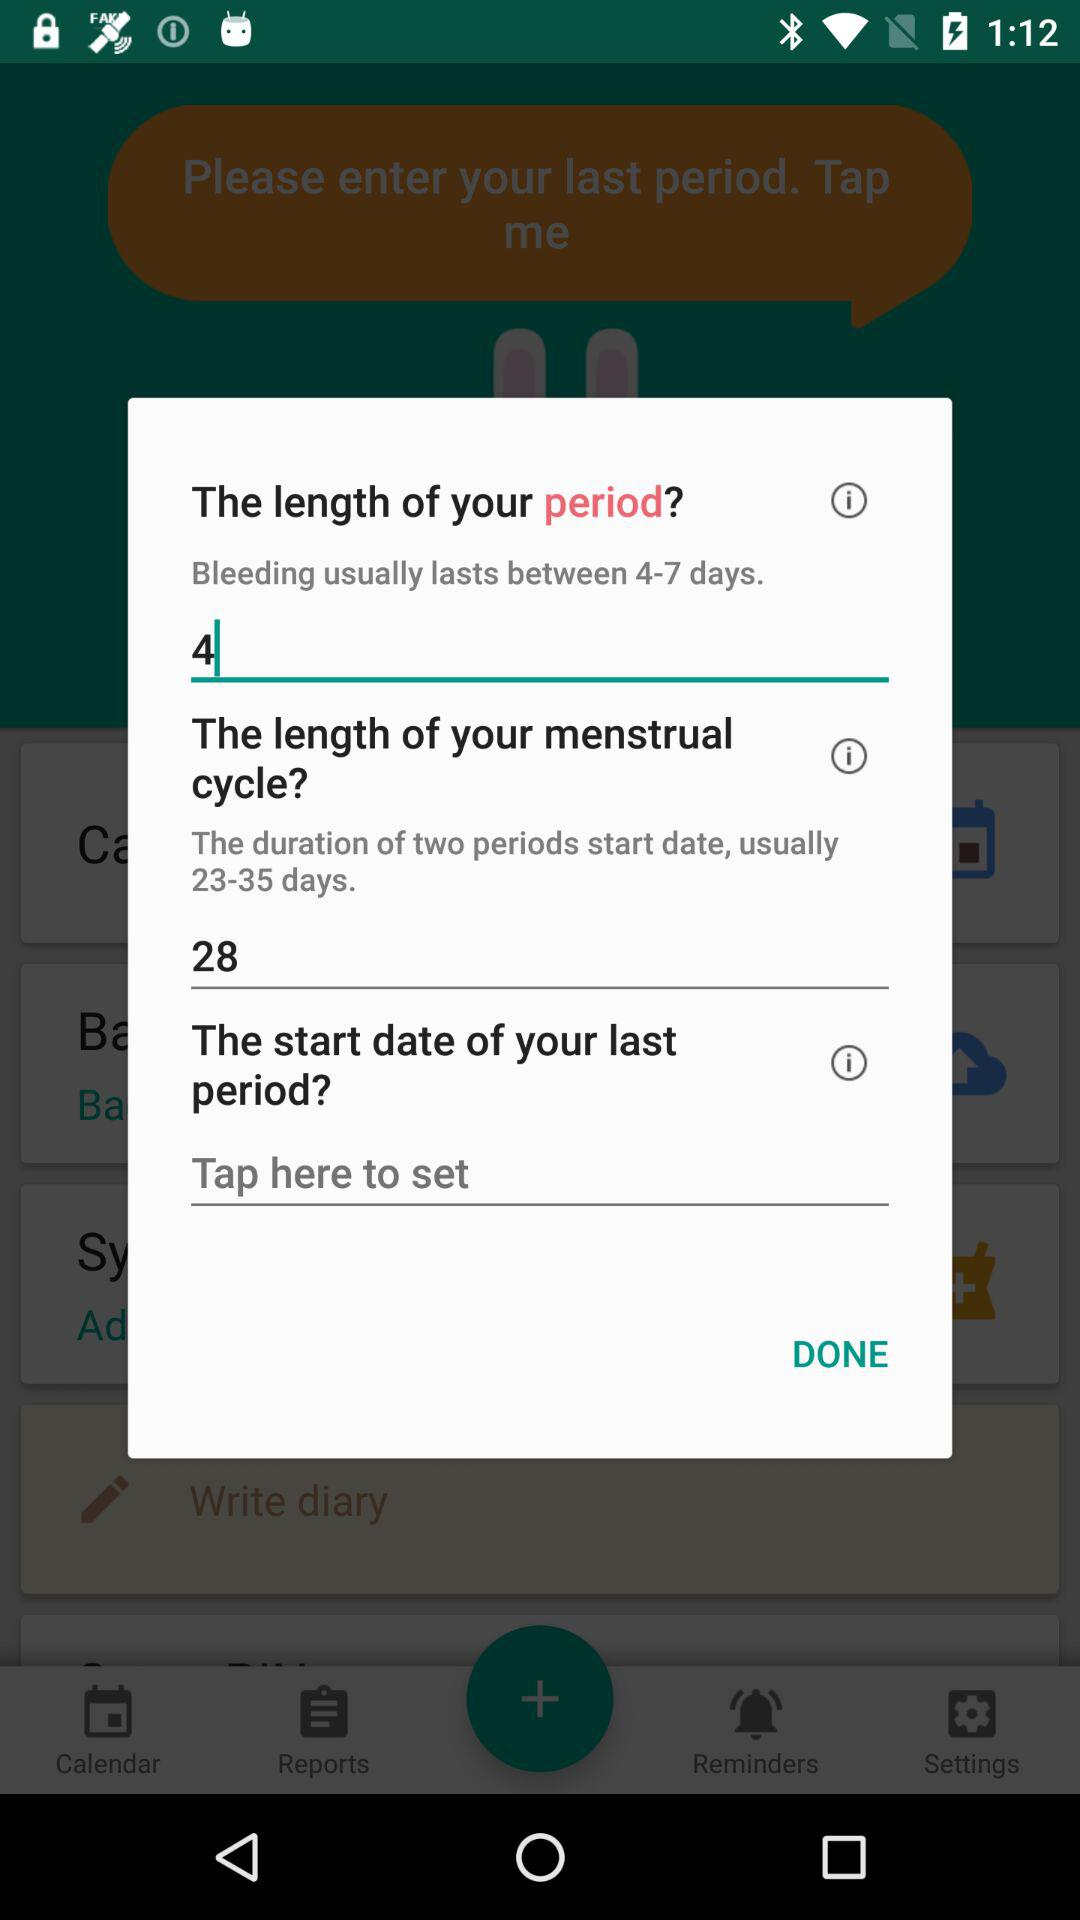What is the duration of two periods start date? The duration is 23 to 35 days. 